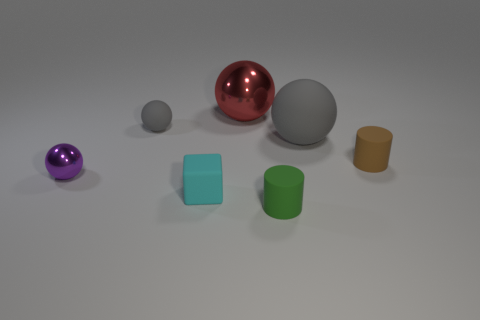There is a shiny thing that is behind the brown object; is its shape the same as the gray thing to the left of the tiny green matte cylinder?
Provide a succinct answer. Yes. How many small green things are behind the red ball?
Make the answer very short. 0. Is there a green cylinder made of the same material as the big gray object?
Your response must be concise. Yes. What is the material of the gray sphere that is the same size as the red thing?
Make the answer very short. Rubber. Is the tiny purple object made of the same material as the big gray ball?
Provide a succinct answer. No. What number of objects are small rubber cylinders or gray balls?
Provide a succinct answer. 4. There is a shiny thing to the left of the cyan rubber block; what is its shape?
Offer a terse response. Sphere. What is the color of the sphere that is made of the same material as the purple object?
Ensure brevity in your answer.  Red. There is a big red object that is the same shape as the big gray matte thing; what is its material?
Ensure brevity in your answer.  Metal. What is the shape of the big gray rubber object?
Your response must be concise. Sphere. 